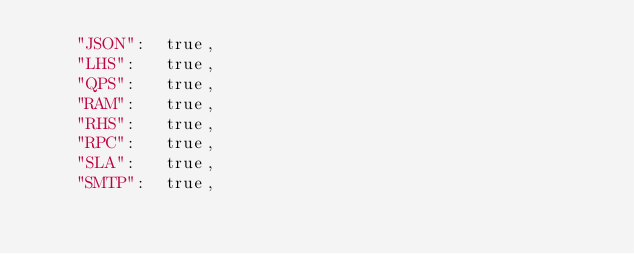Convert code to text. <code><loc_0><loc_0><loc_500><loc_500><_Go_>	"JSON":  true,
	"LHS":   true,
	"QPS":   true,
	"RAM":   true,
	"RHS":   true,
	"RPC":   true,
	"SLA":   true,
	"SMTP":  true,</code> 